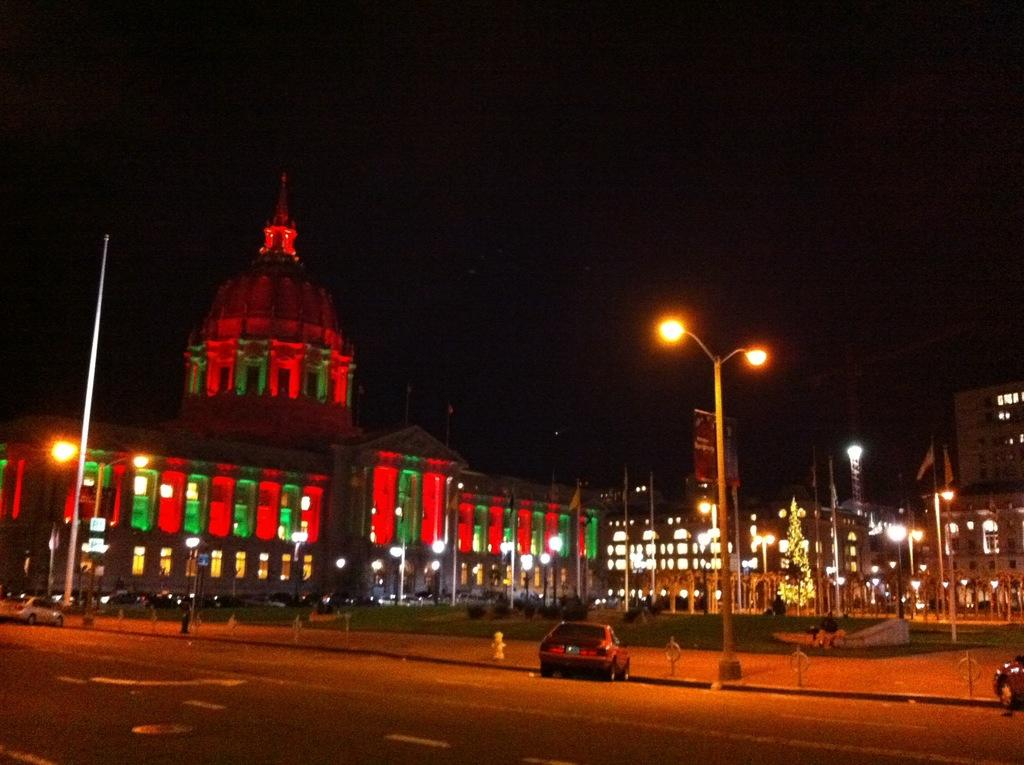At what time of day was the image taken? The image was taken during night time. What type of structure is present in the image? There is a palace in the image. What helps to illuminate the scene in the image? There are light poles in the image. What other structures can be seen in the image? There are buildings in the image. What type of vegetation is present in the image? There is a tree in the image. What type of transportation is visible in the image? Vehicles are visible passing on the road in the image. What type of zipper can be seen on the palace in the image? There are no zippers present on the palace in the image. What is the taste of the tree in the image? Trees do not have a taste, and there is no indication of tasting in the image. 